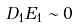<formula> <loc_0><loc_0><loc_500><loc_500>D _ { 1 } E _ { 1 } \sim 0</formula> 